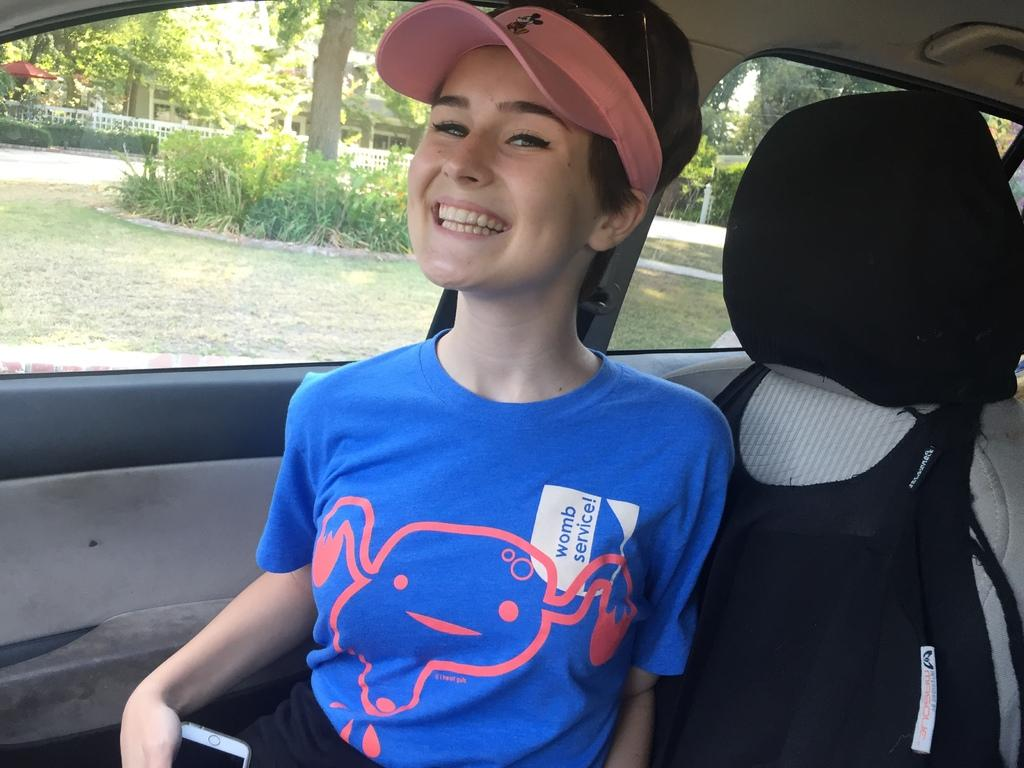Who is present in the image? There is a woman in the image. What is the woman doing in the image? The woman is sitting in a vehicle. What is the woman's expression in the image? The woman is smiling. What can be seen through the glass in the image? Trees, plants, grass, and fencing can be seen through the glass. What type of rose is the woman holding in the image? There is no rose present in the image; the woman is sitting in a vehicle and smiling. Can you tell me how many pigs are visible through the glass in the image? There are no pigs visible through the glass in the image; only trees, plants, grass, and fencing can be seen. 